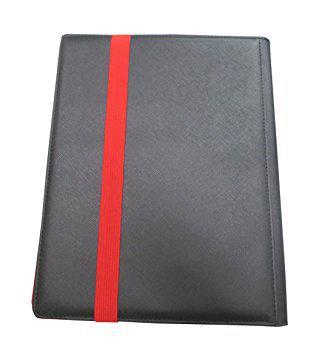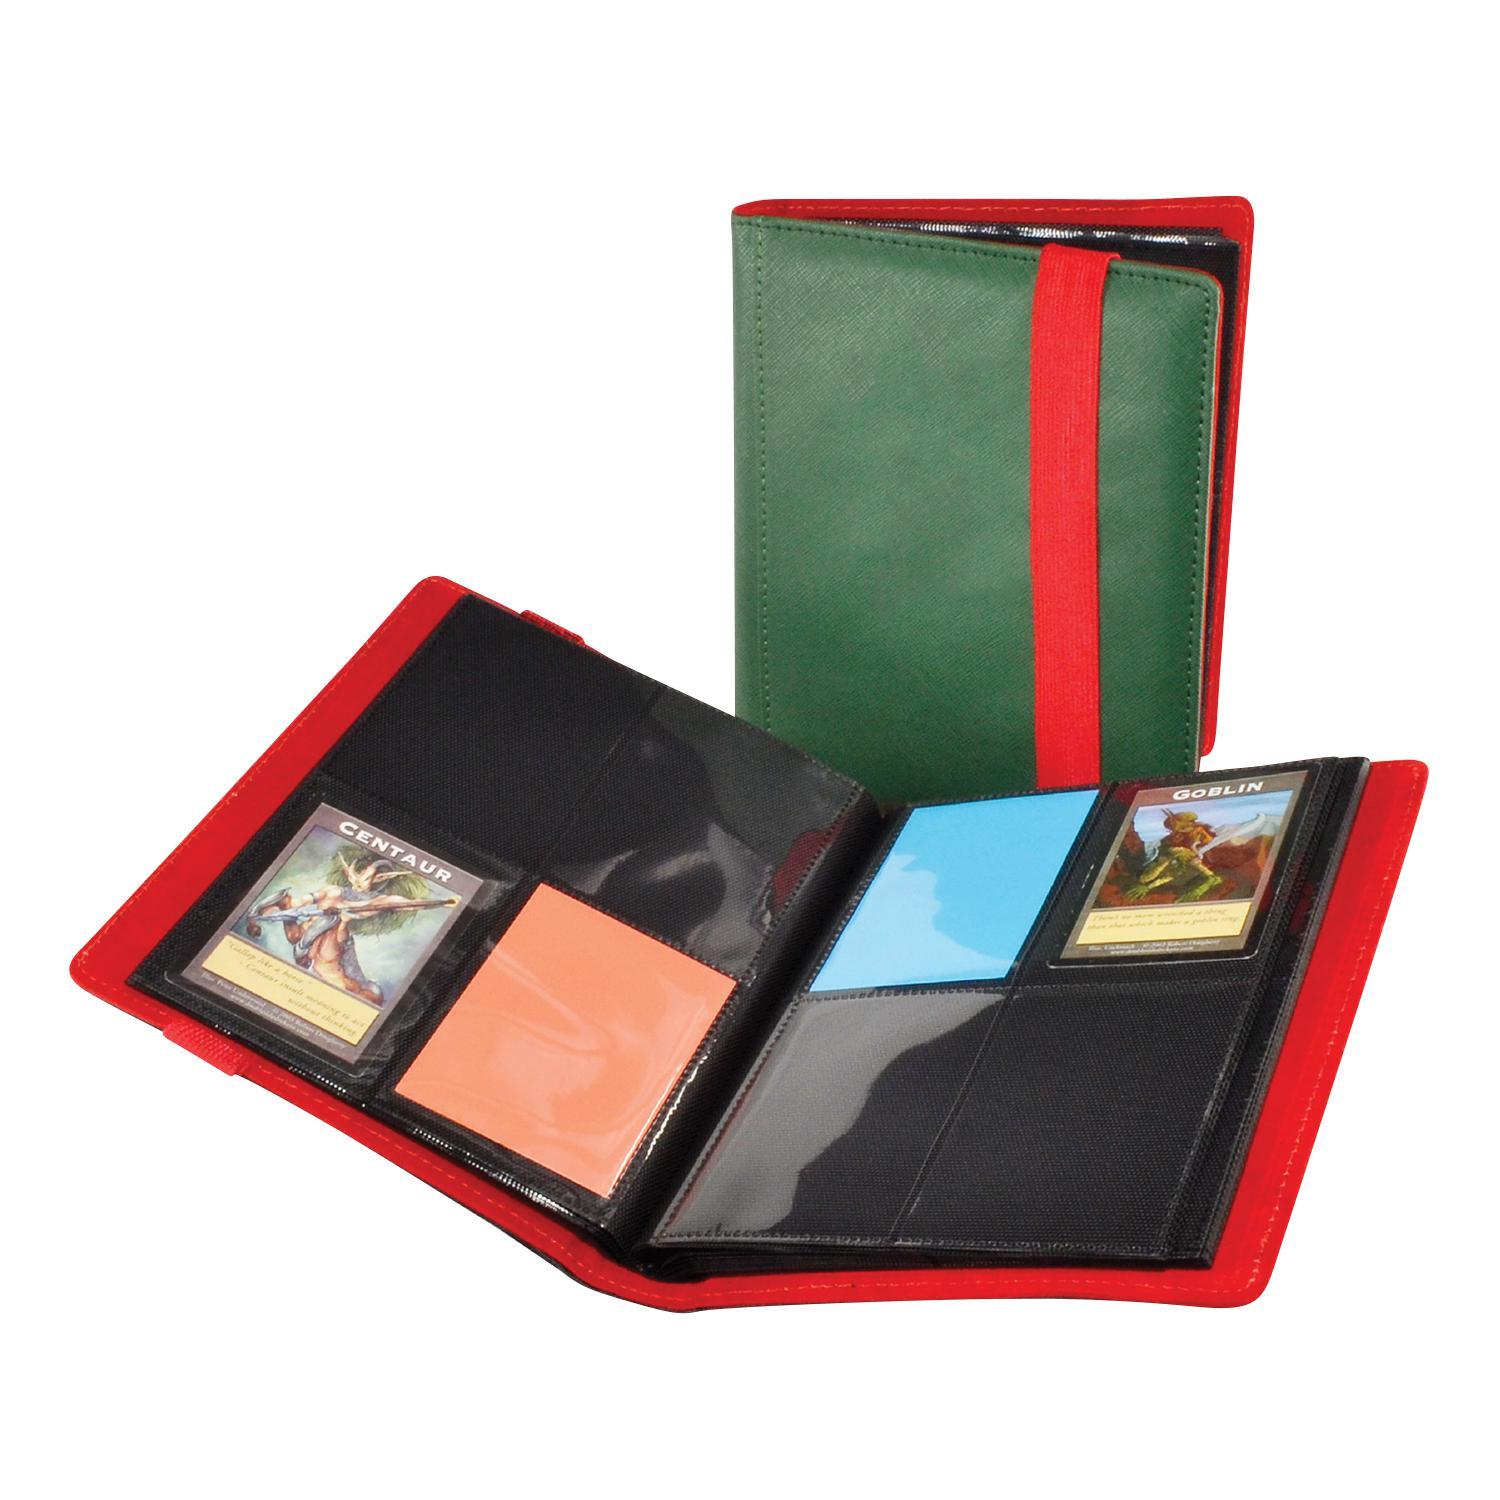The first image is the image on the left, the second image is the image on the right. Given the left and right images, does the statement "There is a single folder on the left image." hold true? Answer yes or no. Yes. 